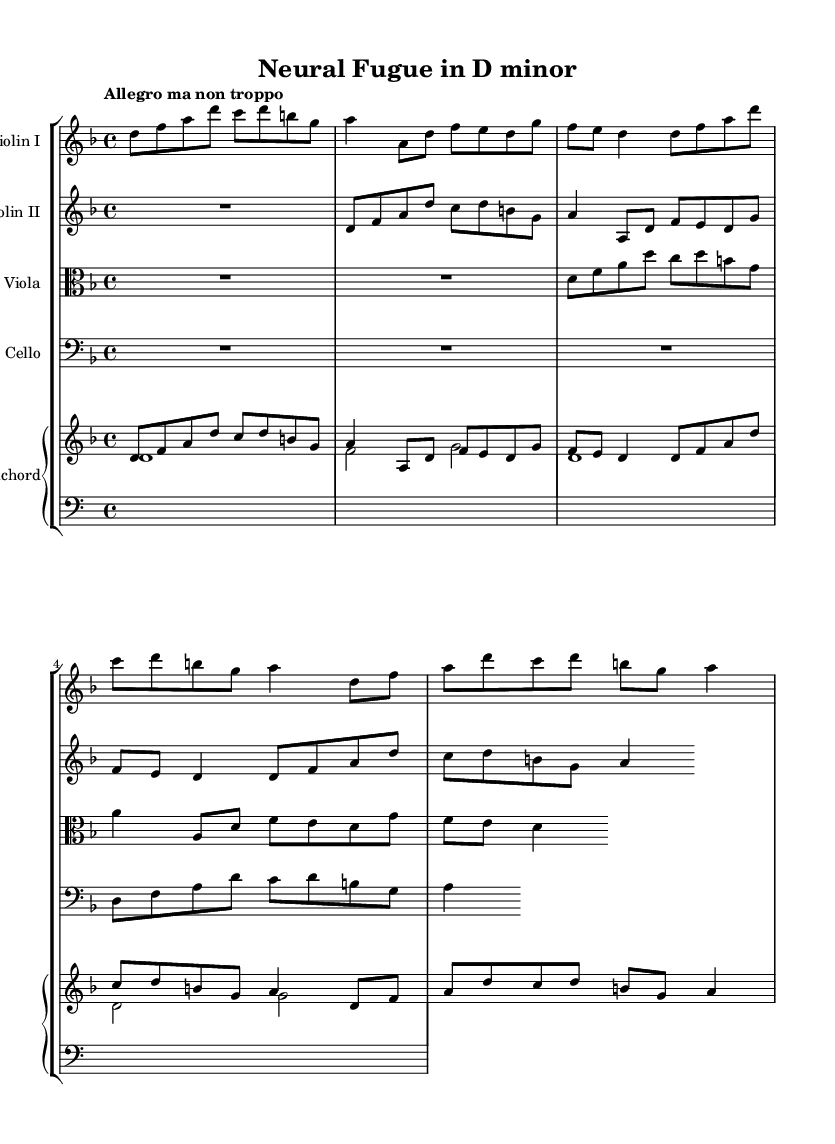What is the key signature of this music? The key signature is D minor, which has one flat (B flat).
Answer: D minor What is the time signature of the piece? The time signature is 4/4, indicating four beats per measure, with each beat being a quarter note.
Answer: 4/4 What is the tempo marking for this piece? The tempo marking is "Allegro ma non troppo," which suggests a lively tempo but not excessively quick.
Answer: Allegro ma non troppo How many instruments are in this chamber music? There are five instruments: two violins, one viola, one cello, and one harpsichord.
Answer: Five What is the starting note for Violin I? The starting note for Violin I is D.
Answer: D Which instrument plays the lowest range? The cello plays the lowest range, typically in the bass clef, below the viola and violins.
Answer: Cello What is one unique characteristic of Baroque music present in this piece? One unique characteristic is the use of counterpoint, where multiple independent melodies are played simultaneously.
Answer: Counterpoint 